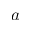<formula> <loc_0><loc_0><loc_500><loc_500>a</formula> 